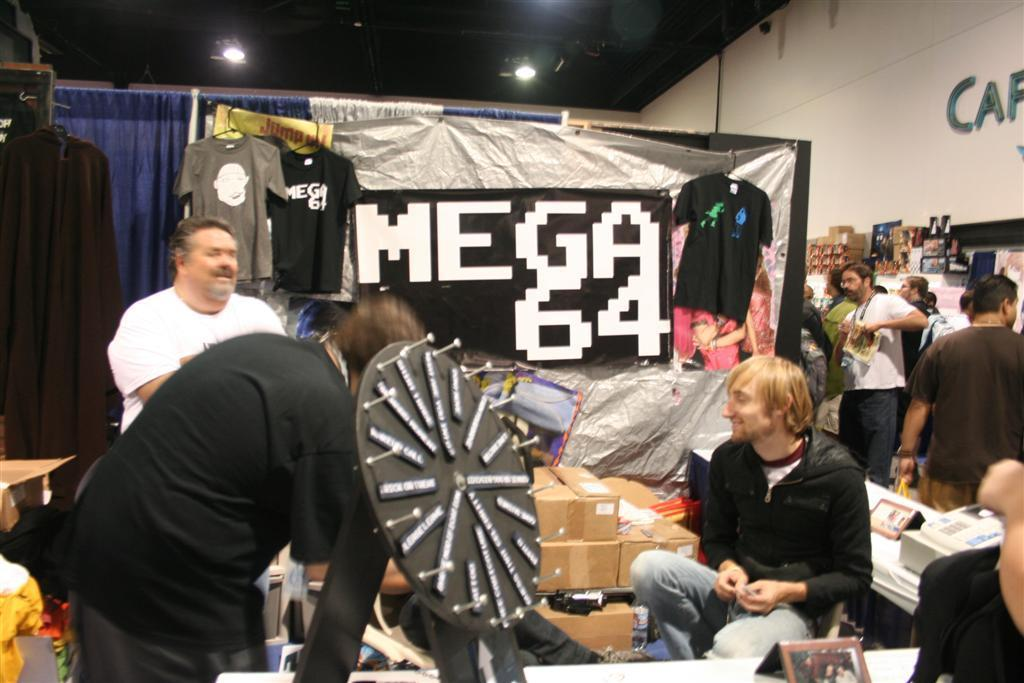How many people are in the image? There is a group of people in the image, but the exact number is not specified. What type of clothing can be seen in the image? Clothes are visible in the image, but the specific styles or colors are not mentioned. What type of window treatment is present in the image? Curtains are present in the image. What type of storage containers are visible in the image? Boxes are present in the image. What other objects can be seen in the image? There are other objects in the image, but their specific types are not mentioned. What can be seen in the background of the image? There is a wall, a roof, and lights visible in the background of the image. What type of leather is used to make the company logo visible on the wall in the image? There is no mention of a company logo or leather in the image. 